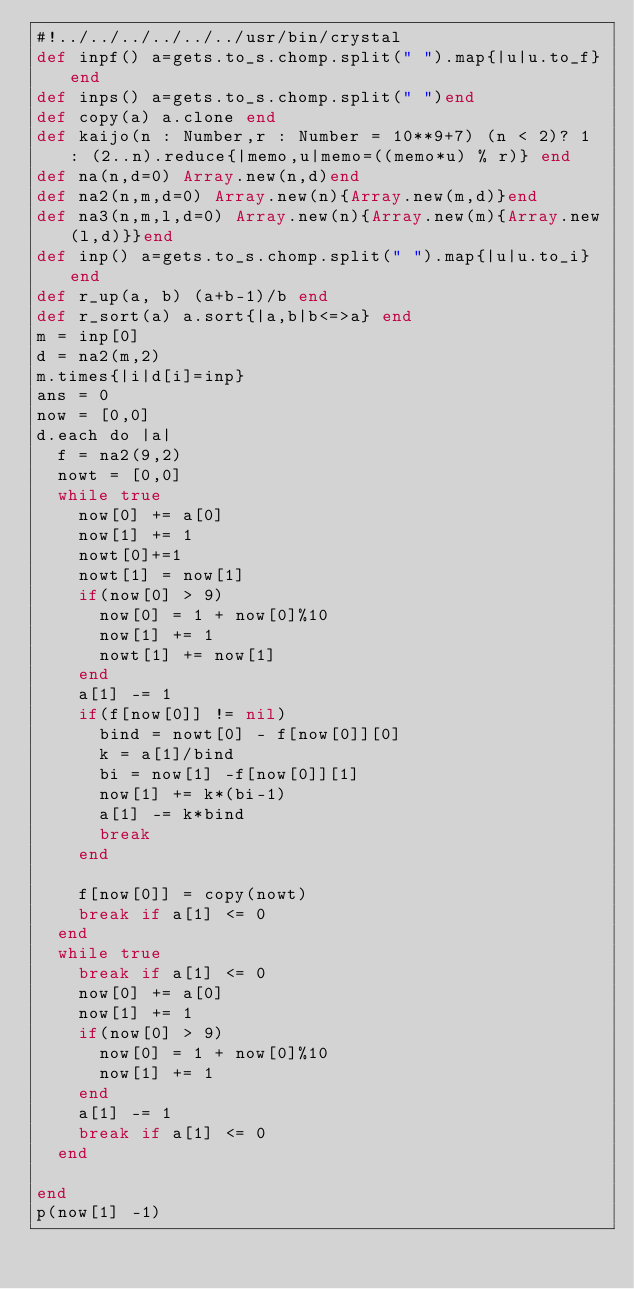Convert code to text. <code><loc_0><loc_0><loc_500><loc_500><_Crystal_>#!../../../../../../usr/bin/crystal
def inpf() a=gets.to_s.chomp.split(" ").map{|u|u.to_f}end
def inps() a=gets.to_s.chomp.split(" ")end
def copy(a) a.clone end
def kaijo(n : Number,r : Number = 10**9+7) (n < 2)? 1 : (2..n).reduce{|memo,u|memo=((memo*u) % r)} end
def na(n,d=0) Array.new(n,d)end
def na2(n,m,d=0) Array.new(n){Array.new(m,d)}end
def na3(n,m,l,d=0) Array.new(n){Array.new(m){Array.new(l,d)}}end
def inp() a=gets.to_s.chomp.split(" ").map{|u|u.to_i}end
def r_up(a, b) (a+b-1)/b end
def r_sort(a) a.sort{|a,b|b<=>a} end
m = inp[0]
d = na2(m,2)
m.times{|i|d[i]=inp}
ans = 0
now = [0,0]
d.each do |a|
  f = na2(9,2)
  nowt = [0,0]
  while true
    now[0] += a[0]
    now[1] += 1
    nowt[0]+=1
    nowt[1] = now[1]
    if(now[0] > 9)
      now[0] = 1 + now[0]%10
      now[1] += 1
      nowt[1] += now[1]
    end
    a[1] -= 1
    if(f[now[0]] != nil)
      bind = nowt[0] - f[now[0]][0]
      k = a[1]/bind
      bi = now[1] -f[now[0]][1]
      now[1] += k*(bi-1)
      a[1] -= k*bind
      break
    end

    f[now[0]] = copy(nowt)
    break if a[1] <= 0
  end
  while true
    break if a[1] <= 0
    now[0] += a[0]
    now[1] += 1
    if(now[0] > 9)
      now[0] = 1 + now[0]%10
      now[1] += 1
    end
    a[1] -= 1
    break if a[1] <= 0
  end

end
p(now[1] -1)</code> 